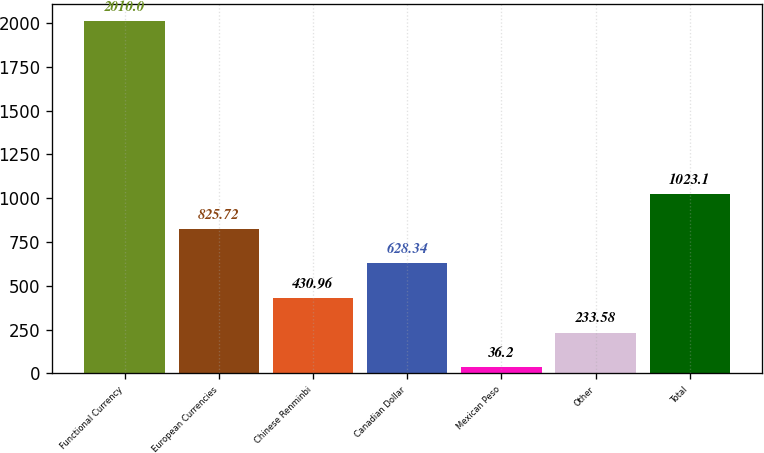Convert chart. <chart><loc_0><loc_0><loc_500><loc_500><bar_chart><fcel>Functional Currency<fcel>European Currencies<fcel>Chinese Renminbi<fcel>Canadian Dollar<fcel>Mexican Peso<fcel>Other<fcel>Total<nl><fcel>2010<fcel>825.72<fcel>430.96<fcel>628.34<fcel>36.2<fcel>233.58<fcel>1023.1<nl></chart> 